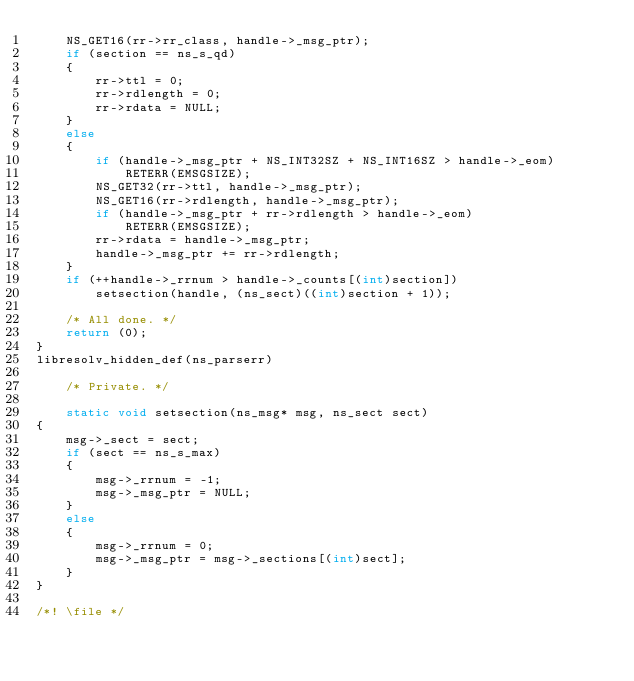Convert code to text. <code><loc_0><loc_0><loc_500><loc_500><_C_>    NS_GET16(rr->rr_class, handle->_msg_ptr);
    if (section == ns_s_qd)
    {
        rr->ttl = 0;
        rr->rdlength = 0;
        rr->rdata = NULL;
    }
    else
    {
        if (handle->_msg_ptr + NS_INT32SZ + NS_INT16SZ > handle->_eom)
            RETERR(EMSGSIZE);
        NS_GET32(rr->ttl, handle->_msg_ptr);
        NS_GET16(rr->rdlength, handle->_msg_ptr);
        if (handle->_msg_ptr + rr->rdlength > handle->_eom)
            RETERR(EMSGSIZE);
        rr->rdata = handle->_msg_ptr;
        handle->_msg_ptr += rr->rdlength;
    }
    if (++handle->_rrnum > handle->_counts[(int)section])
        setsection(handle, (ns_sect)((int)section + 1));

    /* All done. */
    return (0);
}
libresolv_hidden_def(ns_parserr)

    /* Private. */

    static void setsection(ns_msg* msg, ns_sect sect)
{
    msg->_sect = sect;
    if (sect == ns_s_max)
    {
        msg->_rrnum = -1;
        msg->_msg_ptr = NULL;
    }
    else
    {
        msg->_rrnum = 0;
        msg->_msg_ptr = msg->_sections[(int)sect];
    }
}

/*! \file */
</code> 